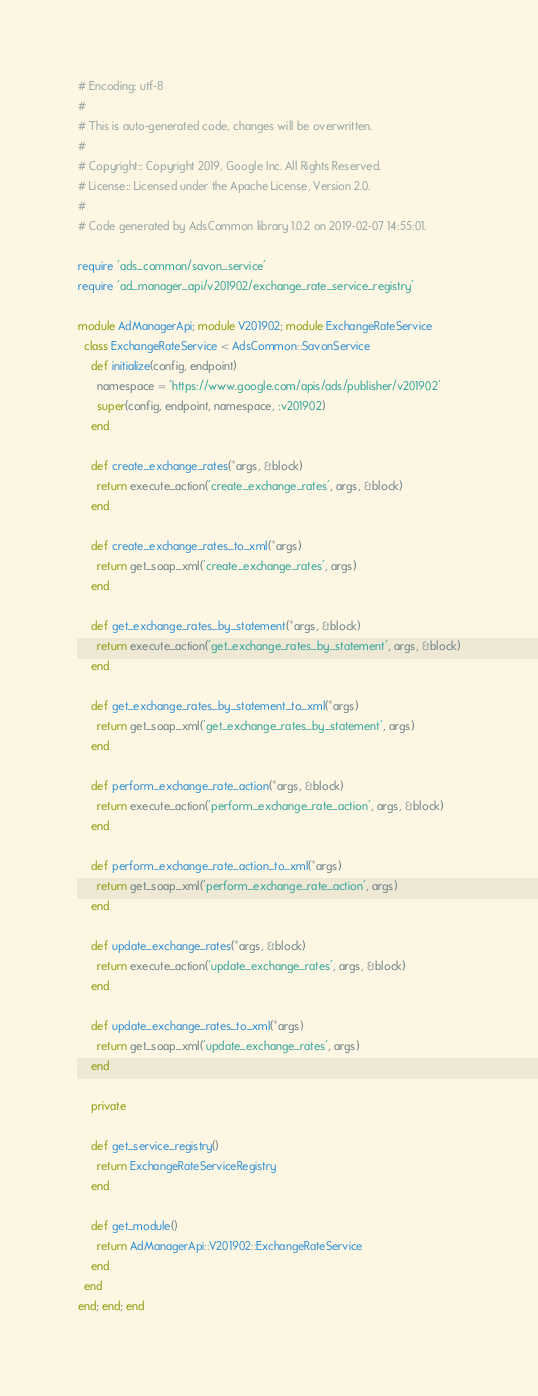<code> <loc_0><loc_0><loc_500><loc_500><_Ruby_># Encoding: utf-8
#
# This is auto-generated code, changes will be overwritten.
#
# Copyright:: Copyright 2019, Google Inc. All Rights Reserved.
# License:: Licensed under the Apache License, Version 2.0.
#
# Code generated by AdsCommon library 1.0.2 on 2019-02-07 14:55:01.

require 'ads_common/savon_service'
require 'ad_manager_api/v201902/exchange_rate_service_registry'

module AdManagerApi; module V201902; module ExchangeRateService
  class ExchangeRateService < AdsCommon::SavonService
    def initialize(config, endpoint)
      namespace = 'https://www.google.com/apis/ads/publisher/v201902'
      super(config, endpoint, namespace, :v201902)
    end

    def create_exchange_rates(*args, &block)
      return execute_action('create_exchange_rates', args, &block)
    end

    def create_exchange_rates_to_xml(*args)
      return get_soap_xml('create_exchange_rates', args)
    end

    def get_exchange_rates_by_statement(*args, &block)
      return execute_action('get_exchange_rates_by_statement', args, &block)
    end

    def get_exchange_rates_by_statement_to_xml(*args)
      return get_soap_xml('get_exchange_rates_by_statement', args)
    end

    def perform_exchange_rate_action(*args, &block)
      return execute_action('perform_exchange_rate_action', args, &block)
    end

    def perform_exchange_rate_action_to_xml(*args)
      return get_soap_xml('perform_exchange_rate_action', args)
    end

    def update_exchange_rates(*args, &block)
      return execute_action('update_exchange_rates', args, &block)
    end

    def update_exchange_rates_to_xml(*args)
      return get_soap_xml('update_exchange_rates', args)
    end

    private

    def get_service_registry()
      return ExchangeRateServiceRegistry
    end

    def get_module()
      return AdManagerApi::V201902::ExchangeRateService
    end
  end
end; end; end
</code> 